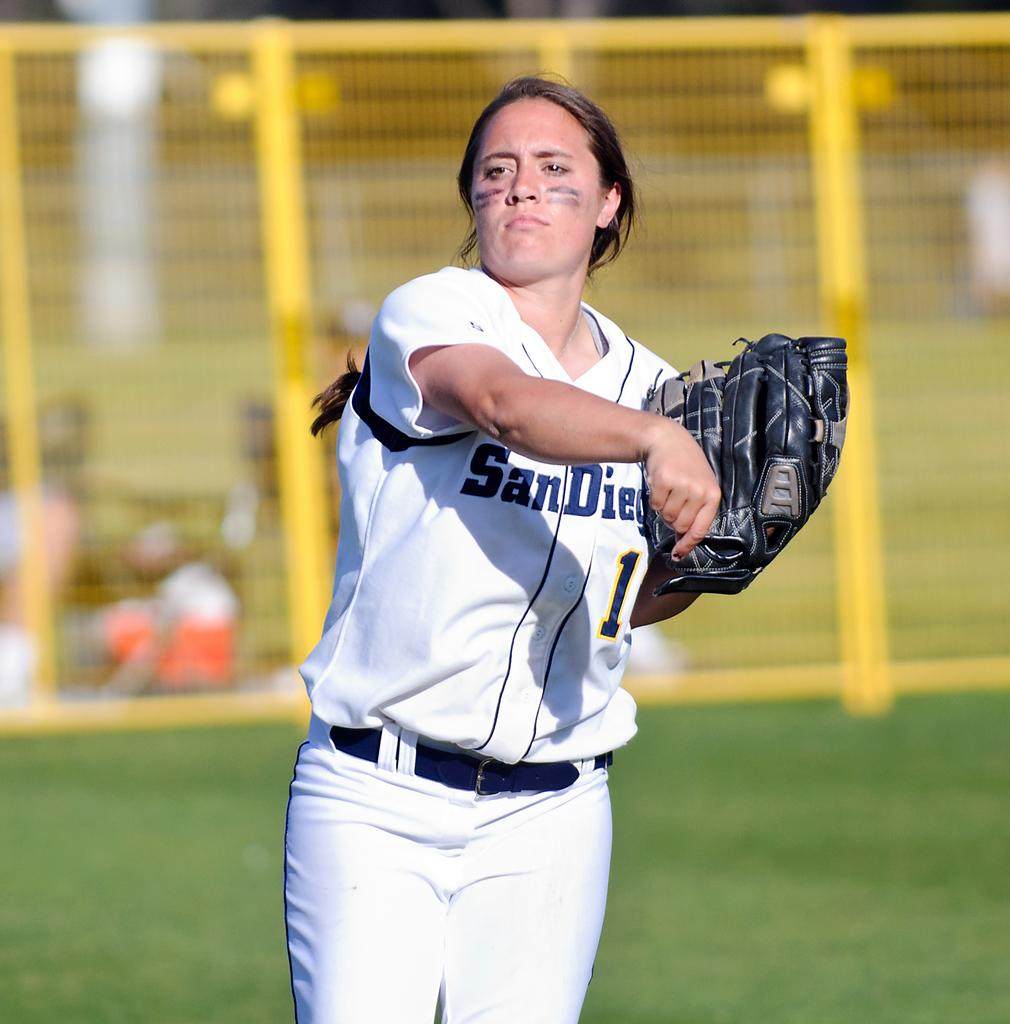<image>
Share a concise interpretation of the image provided. A girl wearing a San Diego softball uniform is holding a black glove. 